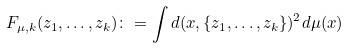Convert formula to latex. <formula><loc_0><loc_0><loc_500><loc_500>F _ { \mu , k } ( z _ { 1 } , \dots , z _ { k } ) \colon = \int d ( x , \{ z _ { 1 } , \dots , z _ { k } \} ) ^ { 2 } d \mu ( x )</formula> 